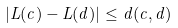<formula> <loc_0><loc_0><loc_500><loc_500>\left | L ( c ) - L ( d ) \right | \leq d ( c , d )</formula> 